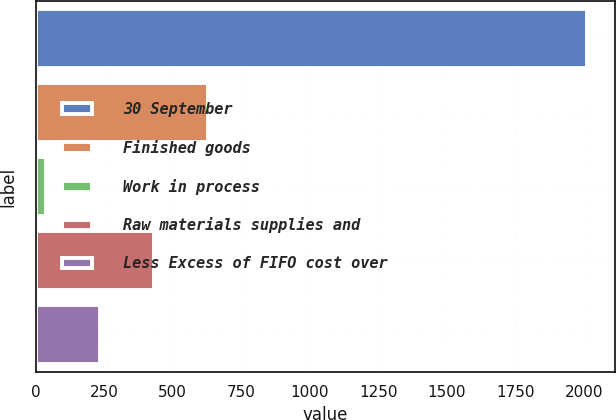Convert chart to OTSL. <chart><loc_0><loc_0><loc_500><loc_500><bar_chart><fcel>30 September<fcel>Finished goods<fcel>Work in process<fcel>Raw materials supplies and<fcel>Less Excess of FIFO cost over<nl><fcel>2012<fcel>629.29<fcel>36.7<fcel>431.76<fcel>234.23<nl></chart> 